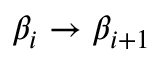Convert formula to latex. <formula><loc_0><loc_0><loc_500><loc_500>\beta _ { i } \to \beta _ { i + 1 }</formula> 